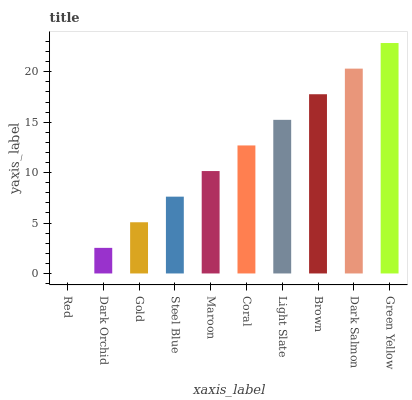Is Dark Orchid the minimum?
Answer yes or no. No. Is Dark Orchid the maximum?
Answer yes or no. No. Is Dark Orchid greater than Red?
Answer yes or no. Yes. Is Red less than Dark Orchid?
Answer yes or no. Yes. Is Red greater than Dark Orchid?
Answer yes or no. No. Is Dark Orchid less than Red?
Answer yes or no. No. Is Coral the high median?
Answer yes or no. Yes. Is Maroon the low median?
Answer yes or no. Yes. Is Red the high median?
Answer yes or no. No. Is Dark Orchid the low median?
Answer yes or no. No. 